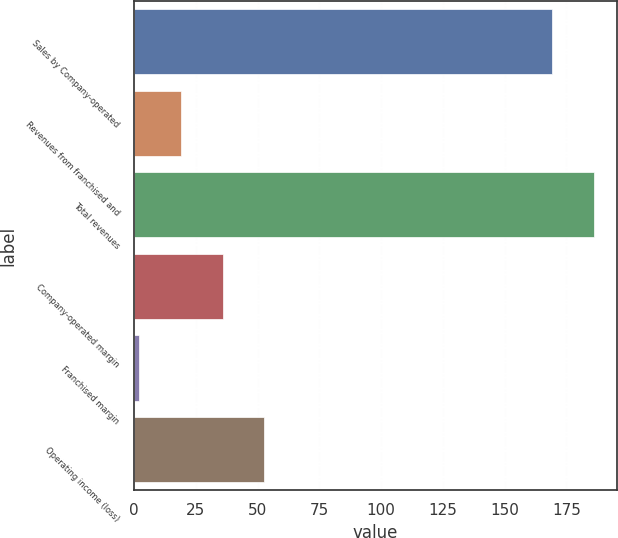Convert chart to OTSL. <chart><loc_0><loc_0><loc_500><loc_500><bar_chart><fcel>Sales by Company-operated<fcel>Revenues from franchised and<fcel>Total revenues<fcel>Company-operated margin<fcel>Franchised margin<fcel>Operating income (loss)<nl><fcel>169<fcel>18.85<fcel>185.95<fcel>35.8<fcel>1.9<fcel>52.75<nl></chart> 